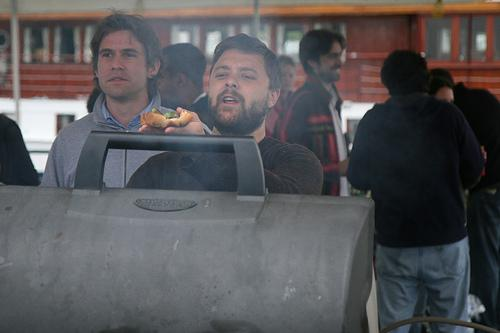Question: what color is the grill?
Choices:
A. White.
B. Black.
C. Grey.
D. Blue.
Answer with the letter. Answer: B Question: what color are the shelves?
Choices:
A. Blue.
B. Red.
C. Green.
D. Brown.
Answer with the letter. Answer: D Question: who is holding grill open?
Choices:
A. A woman.
B. A child.
C. Bearded Man.
D. The bartender.
Answer with the letter. Answer: C Question: what is in bearded man's hand?
Choices:
A. Plate.
B. Knife.
C. Food.
D. Spoon.
Answer with the letter. Answer: C 